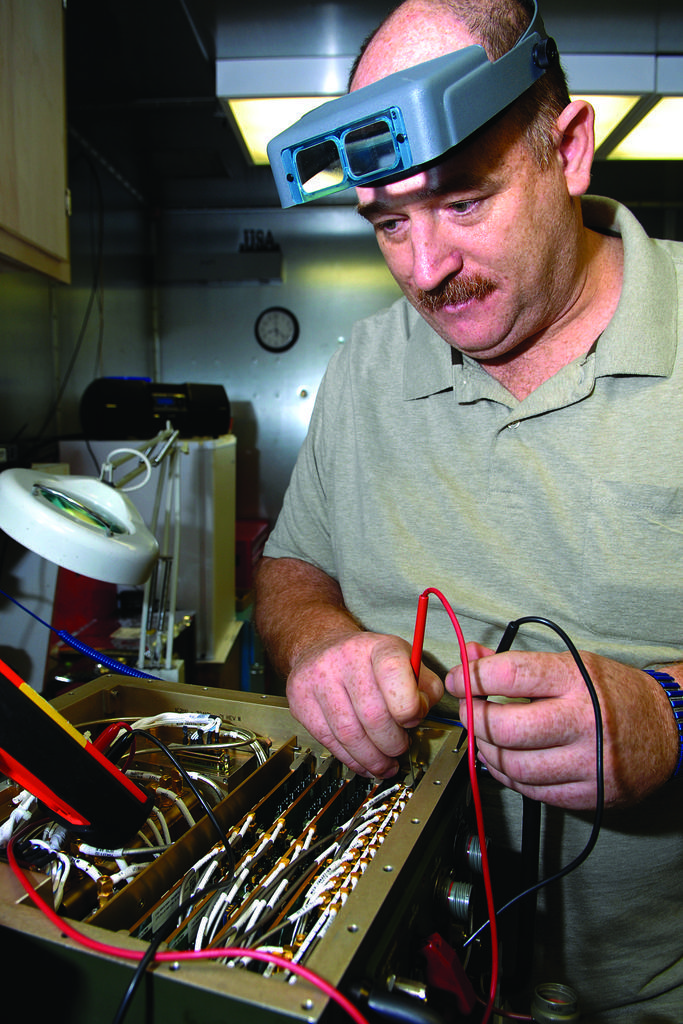Describe this image in one or two sentences. This image consists of a man. He is wearing a green shirt. There is a machine in front of him. He is doing something. 